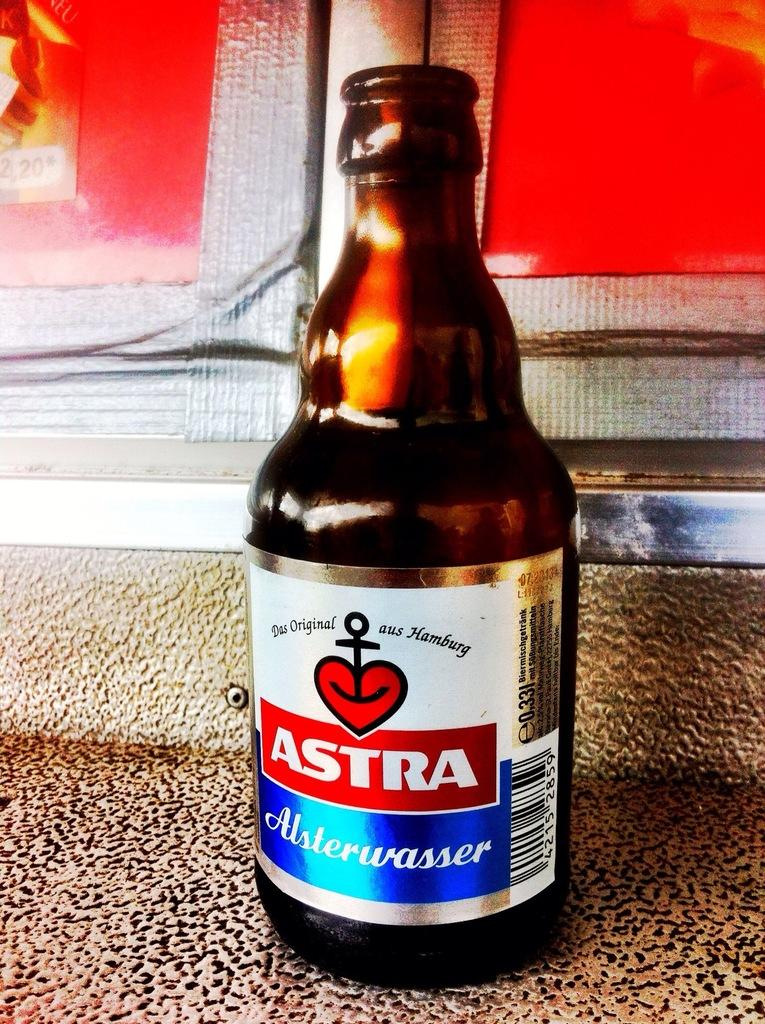Provide a one-sentence caption for the provided image. An open bottle of Astra sits on a textured surface. 